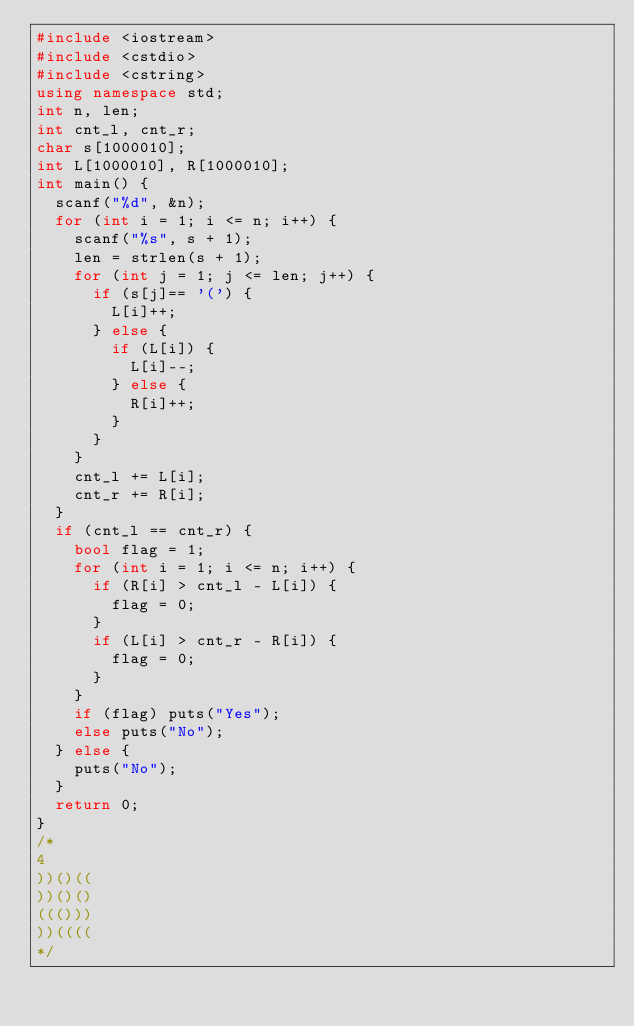<code> <loc_0><loc_0><loc_500><loc_500><_C++_>#include <iostream>
#include <cstdio>
#include <cstring>
using namespace std;
int n, len;
int cnt_l, cnt_r;
char s[1000010];
int L[1000010], R[1000010];
int main() {
	scanf("%d", &n);
	for (int i = 1; i <= n; i++) {
		scanf("%s", s + 1);
		len = strlen(s + 1);
		for (int j = 1; j <= len; j++) {
			if (s[j]== '(') {
				L[i]++;
			} else {
				if (L[i]) {
					L[i]--;
				} else {
					R[i]++;
				}
			}
		}
		cnt_l += L[i];
		cnt_r += R[i];
	}
	if (cnt_l == cnt_r) {
		bool flag = 1;
		for (int i = 1; i <= n; i++) {
			if (R[i] > cnt_l - L[i]) {
				flag = 0;
			}
			if (L[i] > cnt_r - R[i]) {
				flag = 0;
			}
		}
		if (flag) puts("Yes");
		else puts("No");
	} else {
		puts("No");
	}
	return 0;
}
/*
4
))()((
))()()
((()))
))((((
*/</code> 